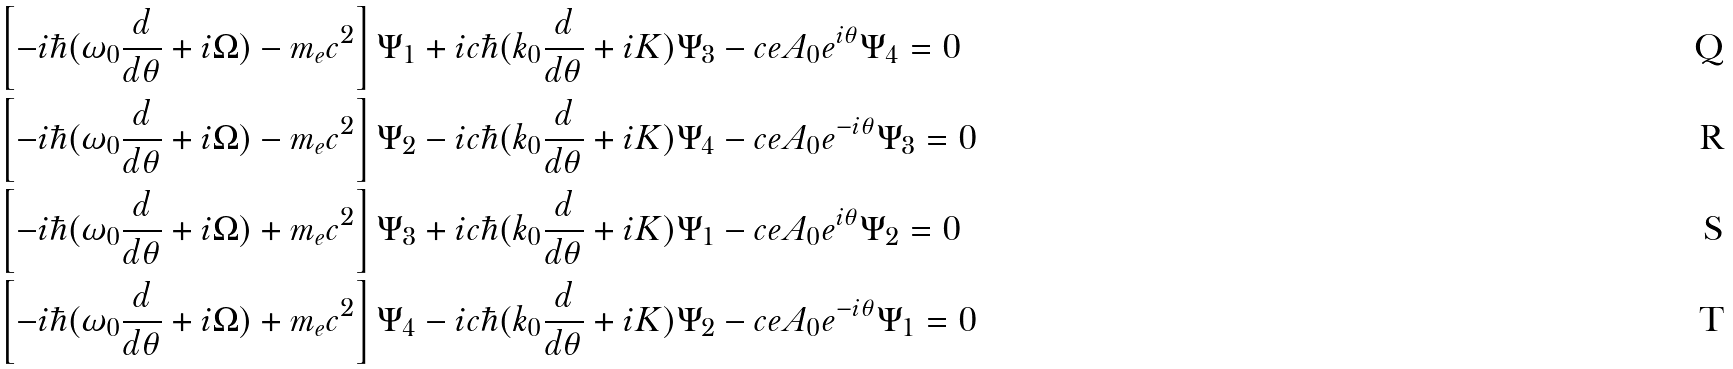<formula> <loc_0><loc_0><loc_500><loc_500>& \left [ - i \hbar { ( } \omega _ { 0 } \frac { d } { d \theta } + i \Omega ) - m _ { e } c ^ { 2 } \right ] \Psi _ { 1 } + i c \hbar { ( } k _ { 0 } \frac { d } { d \theta } + i K ) \Psi _ { 3 } - c e A _ { 0 } e ^ { i \theta } \Psi _ { 4 } = 0 \\ & \left [ - i \hbar { ( } \omega _ { 0 } \frac { d } { d \theta } + i \Omega ) - m _ { e } c ^ { 2 } \right ] \Psi _ { 2 } - i c \hbar { ( } k _ { 0 } \frac { d } { d \theta } + i K ) \Psi _ { 4 } - c e A _ { 0 } e ^ { - i \theta } \Psi _ { 3 } = 0 \\ & \left [ - i \hbar { ( } \omega _ { 0 } \frac { d } { d \theta } + i \Omega ) + m _ { e } c ^ { 2 } \right ] \Psi _ { 3 } + i c \hbar { ( } k _ { 0 } \frac { d } { d \theta } + i K ) \Psi _ { 1 } - c e A _ { 0 } e ^ { i \theta } \Psi _ { 2 } = 0 \\ & \left [ - i \hbar { ( } \omega _ { 0 } \frac { d } { d \theta } + i \Omega ) + m _ { e } c ^ { 2 } \right ] \Psi _ { 4 } - i c \hbar { ( } k _ { 0 } \frac { d } { d \theta } + i K ) \Psi _ { 2 } - c e A _ { 0 } e ^ { - i \theta } \Psi _ { 1 } = 0</formula> 